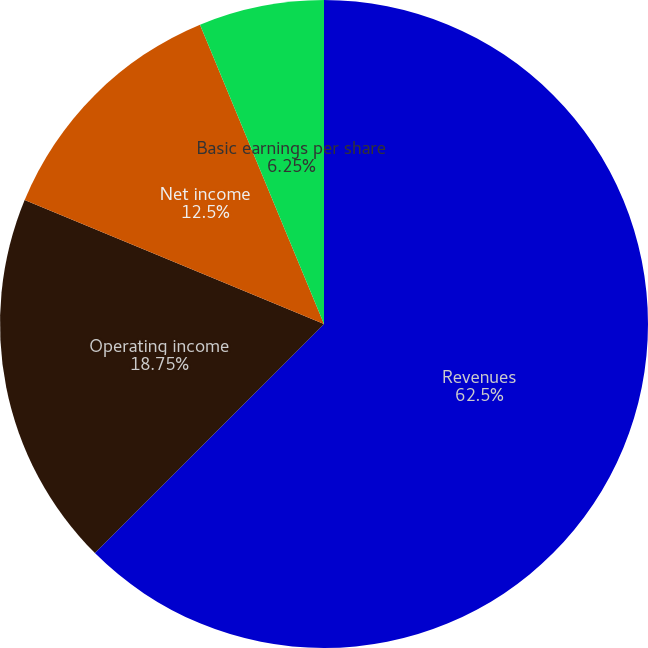<chart> <loc_0><loc_0><loc_500><loc_500><pie_chart><fcel>Revenues<fcel>Operating income<fcel>Net income<fcel>Basic earnings per share<fcel>Diluted earnings per share<nl><fcel>62.5%<fcel>18.75%<fcel>12.5%<fcel>6.25%<fcel>0.0%<nl></chart> 